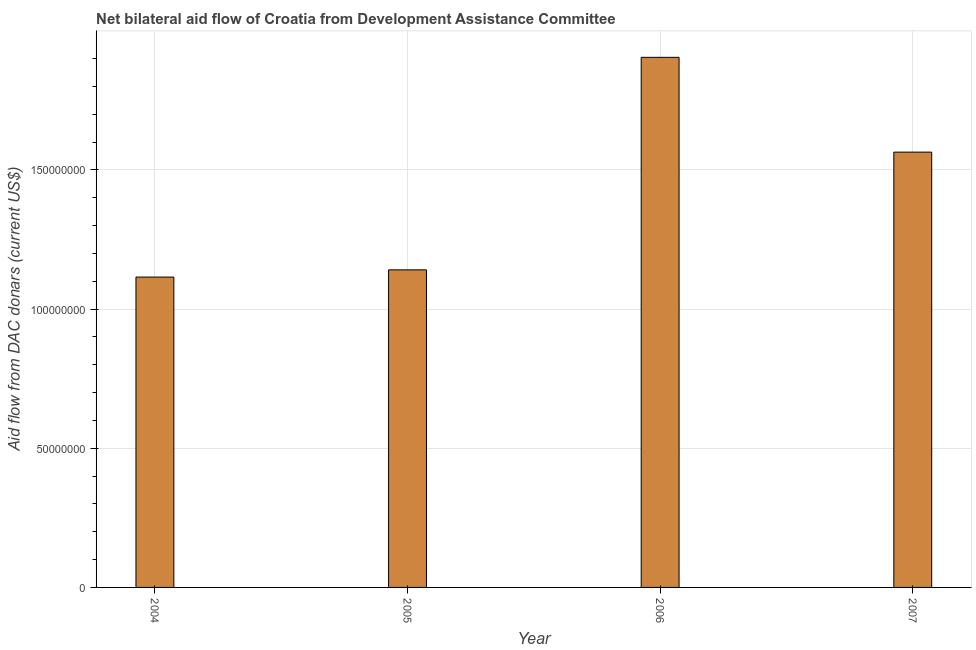What is the title of the graph?
Provide a short and direct response. Net bilateral aid flow of Croatia from Development Assistance Committee. What is the label or title of the Y-axis?
Give a very brief answer. Aid flow from DAC donars (current US$). What is the net bilateral aid flows from dac donors in 2006?
Give a very brief answer. 1.90e+08. Across all years, what is the maximum net bilateral aid flows from dac donors?
Offer a very short reply. 1.90e+08. Across all years, what is the minimum net bilateral aid flows from dac donors?
Make the answer very short. 1.12e+08. In which year was the net bilateral aid flows from dac donors maximum?
Your answer should be compact. 2006. What is the sum of the net bilateral aid flows from dac donors?
Your response must be concise. 5.72e+08. What is the difference between the net bilateral aid flows from dac donors in 2006 and 2007?
Ensure brevity in your answer.  3.41e+07. What is the average net bilateral aid flows from dac donors per year?
Offer a very short reply. 1.43e+08. What is the median net bilateral aid flows from dac donors?
Your response must be concise. 1.35e+08. In how many years, is the net bilateral aid flows from dac donors greater than 50000000 US$?
Your answer should be very brief. 4. What is the ratio of the net bilateral aid flows from dac donors in 2004 to that in 2006?
Provide a succinct answer. 0.58. What is the difference between the highest and the second highest net bilateral aid flows from dac donors?
Provide a succinct answer. 3.41e+07. What is the difference between the highest and the lowest net bilateral aid flows from dac donors?
Provide a short and direct response. 7.90e+07. In how many years, is the net bilateral aid flows from dac donors greater than the average net bilateral aid flows from dac donors taken over all years?
Your answer should be compact. 2. Are all the bars in the graph horizontal?
Your answer should be very brief. No. What is the difference between two consecutive major ticks on the Y-axis?
Your answer should be compact. 5.00e+07. What is the Aid flow from DAC donars (current US$) of 2004?
Your response must be concise. 1.12e+08. What is the Aid flow from DAC donars (current US$) of 2005?
Keep it short and to the point. 1.14e+08. What is the Aid flow from DAC donars (current US$) of 2006?
Ensure brevity in your answer.  1.90e+08. What is the Aid flow from DAC donars (current US$) of 2007?
Keep it short and to the point. 1.56e+08. What is the difference between the Aid flow from DAC donars (current US$) in 2004 and 2005?
Provide a short and direct response. -2.59e+06. What is the difference between the Aid flow from DAC donars (current US$) in 2004 and 2006?
Provide a succinct answer. -7.90e+07. What is the difference between the Aid flow from DAC donars (current US$) in 2004 and 2007?
Provide a short and direct response. -4.49e+07. What is the difference between the Aid flow from DAC donars (current US$) in 2005 and 2006?
Keep it short and to the point. -7.64e+07. What is the difference between the Aid flow from DAC donars (current US$) in 2005 and 2007?
Your answer should be very brief. -4.23e+07. What is the difference between the Aid flow from DAC donars (current US$) in 2006 and 2007?
Keep it short and to the point. 3.41e+07. What is the ratio of the Aid flow from DAC donars (current US$) in 2004 to that in 2005?
Ensure brevity in your answer.  0.98. What is the ratio of the Aid flow from DAC donars (current US$) in 2004 to that in 2006?
Offer a terse response. 0.58. What is the ratio of the Aid flow from DAC donars (current US$) in 2004 to that in 2007?
Provide a short and direct response. 0.71. What is the ratio of the Aid flow from DAC donars (current US$) in 2005 to that in 2006?
Offer a terse response. 0.6. What is the ratio of the Aid flow from DAC donars (current US$) in 2005 to that in 2007?
Make the answer very short. 0.73. What is the ratio of the Aid flow from DAC donars (current US$) in 2006 to that in 2007?
Ensure brevity in your answer.  1.22. 